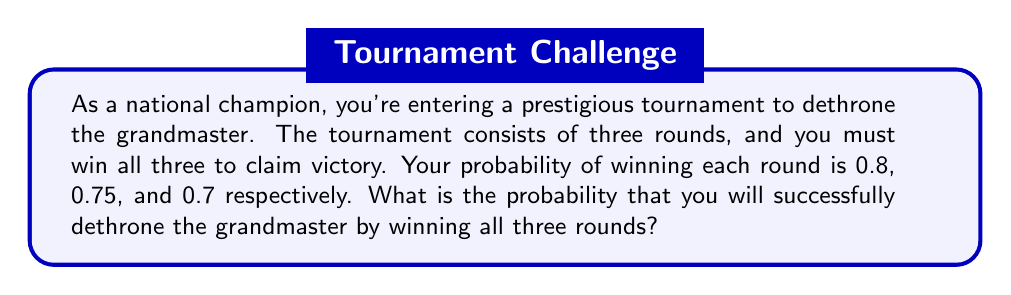Give your solution to this math problem. To solve this problem, we need to use the multiplication rule of probability for independent events. Since you need to win all three rounds, we multiply the probabilities of winning each round:

1. Probability of winning the first round: $P(\text{Round 1}) = 0.8$
2. Probability of winning the second round: $P(\text{Round 2}) = 0.75$
3. Probability of winning the third round: $P(\text{Round 3}) = 0.7$

The probability of winning all three rounds is:

$$P(\text{All Rounds}) = P(\text{Round 1}) \times P(\text{Round 2}) \times P(\text{Round 3})$$

Substituting the values:

$$P(\text{All Rounds}) = 0.8 \times 0.75 \times 0.7$$

Calculating:

$$P(\text{All Rounds}) = 0.42$$

Therefore, the probability of successfully dethroning the grandmaster by winning all three rounds is 0.42 or 42%.
Answer: 0.42 